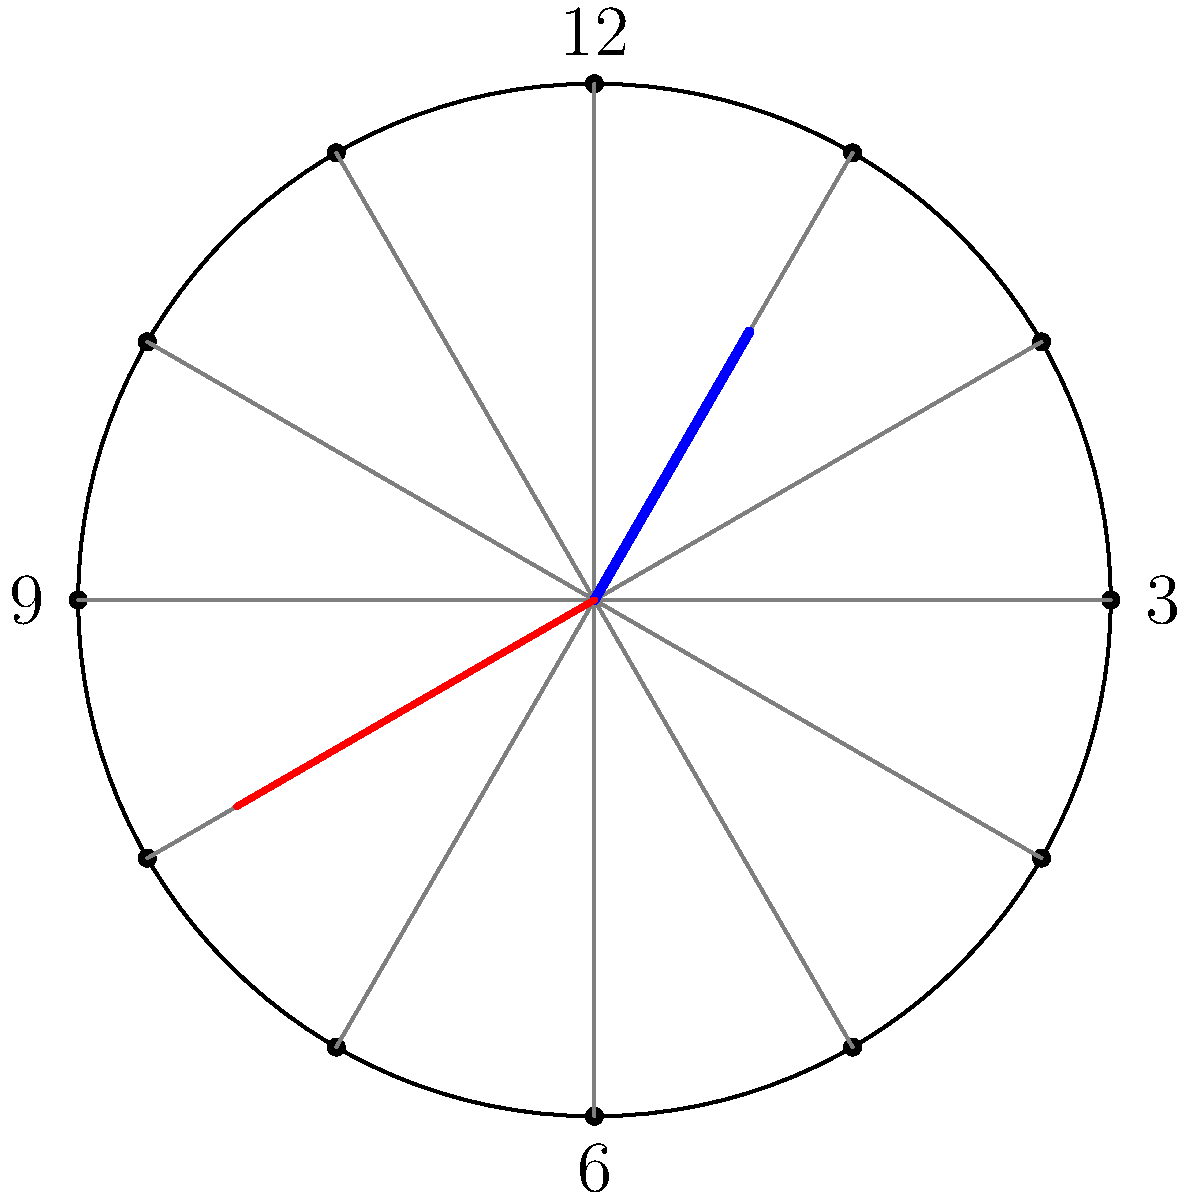Given a custom clock face implementation using polar coordinates, where the hour hand is at 60° and the minute hand is at 210°, what time is being displayed? Express your answer in hours and minutes, separated by a colon. To solve this problem, we need to follow these steps:

1. Understand the polar coordinate system for the clock:
   - 0° (or 360°) represents 12 o'clock
   - Each 30° represents 1 hour
   - Each 6° represents 1 minute

2. Calculate the hour:
   - The hour hand is at 60°
   - 60° ÷ 30° = 2
   - So the hour is 2

3. Calculate the minutes:
   - The minute hand is at 210°
   - 210° ÷ 6° = 35
   - So the number of minutes is 35

4. Combine the results:
   The time displayed is 2:35

In UIKit implementation, you would use these angles to calculate the rotation transforms for the clock hands:

```swift
let hourAngle = CGFloat(60 * .pi / 180)
let minuteAngle = CGFloat(210 * .pi / 180)

hourHandView.transform = CGAffineTransform(rotationAngle: hourAngle)
minuteHandView.transform = CGAffineTransform(rotationAngle: minuteAngle)
```
Answer: 2:35 